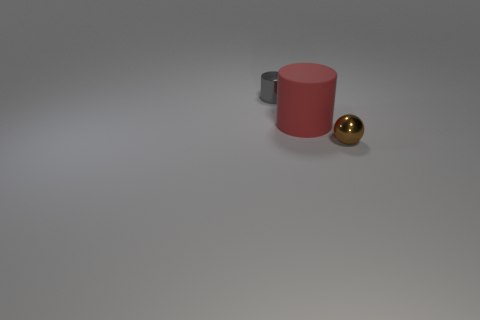The metal thing that is the same size as the brown sphere is what shape?
Give a very brief answer. Cylinder. Is there a big purple metal object of the same shape as the brown thing?
Your answer should be compact. No. Does the tiny gray cylinder have the same material as the small object in front of the big matte cylinder?
Make the answer very short. Yes. What material is the small object that is behind the sphere in front of the big cylinder?
Your response must be concise. Metal. Are there more big red things behind the matte cylinder than balls?
Your answer should be compact. No. Are there any tiny green metallic cylinders?
Give a very brief answer. No. What is the color of the metallic thing that is on the right side of the gray cylinder?
Your answer should be very brief. Brown. There is a object that is the same size as the gray metal cylinder; what is its material?
Your answer should be compact. Metal. What number of other objects are the same material as the small brown ball?
Ensure brevity in your answer.  1. There is a thing that is to the left of the tiny ball and in front of the small cylinder; what color is it?
Ensure brevity in your answer.  Red. 